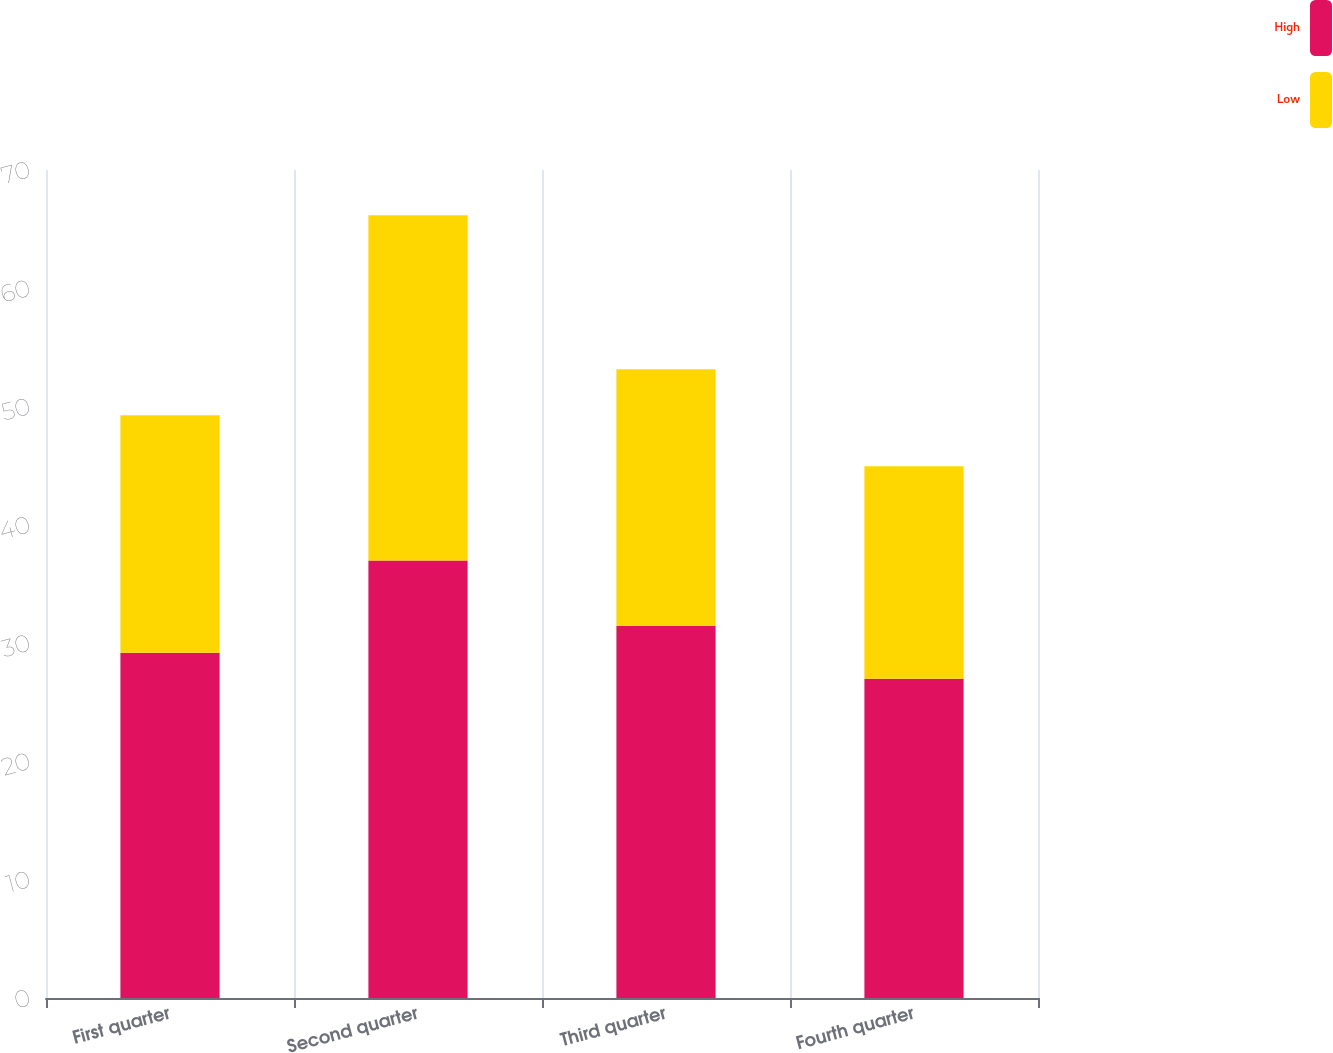Convert chart to OTSL. <chart><loc_0><loc_0><loc_500><loc_500><stacked_bar_chart><ecel><fcel>First quarter<fcel>Second quarter<fcel>Third quarter<fcel>Fourth quarter<nl><fcel>High<fcel>29.18<fcel>36.98<fcel>31.46<fcel>27<nl><fcel>Low<fcel>20.08<fcel>29.19<fcel>21.7<fcel>17.96<nl></chart> 